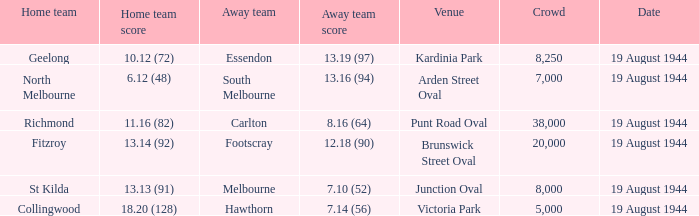What is Fitzroy's Home team Crowd? 20000.0. 